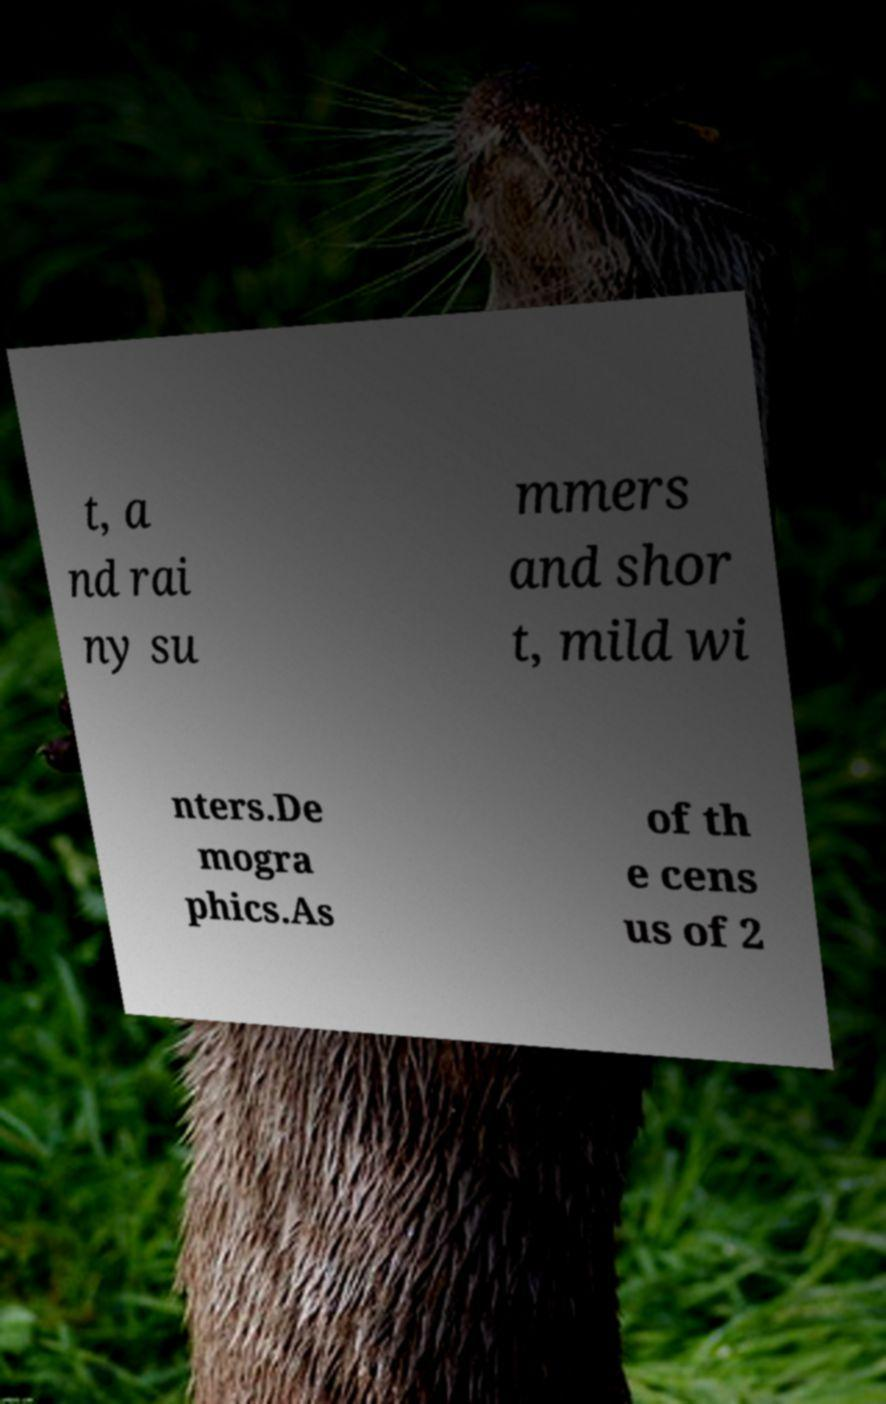For documentation purposes, I need the text within this image transcribed. Could you provide that? t, a nd rai ny su mmers and shor t, mild wi nters.De mogra phics.As of th e cens us of 2 